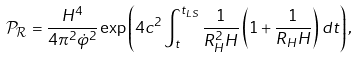Convert formula to latex. <formula><loc_0><loc_0><loc_500><loc_500>\mathcal { P } _ { \mathcal { R } } = \frac { H ^ { 4 } } { 4 \pi ^ { 2 } \dot { \varphi } ^ { 2 } } \exp \left ( 4 c ^ { 2 } \int _ { t } ^ { t _ { L S } } \frac { 1 } { R _ { H } ^ { 2 } H } \left ( 1 + \frac { 1 } { R _ { H } H } \right ) d t \right ) ,</formula> 